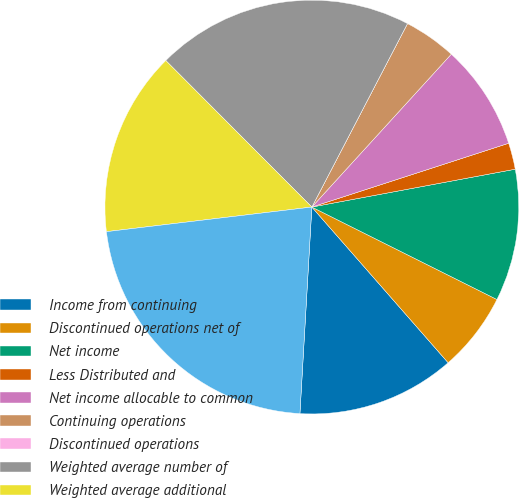<chart> <loc_0><loc_0><loc_500><loc_500><pie_chart><fcel>Income from continuing<fcel>Discontinued operations net of<fcel>Net income<fcel>Less Distributed and<fcel>Net income allocable to common<fcel>Continuing operations<fcel>Discontinued operations<fcel>Weighted average number of<fcel>Weighted average additional<fcel>Shares-diluted basis<nl><fcel>12.36%<fcel>6.18%<fcel>10.3%<fcel>2.06%<fcel>8.24%<fcel>4.12%<fcel>0.0%<fcel>20.12%<fcel>14.42%<fcel>22.18%<nl></chart> 